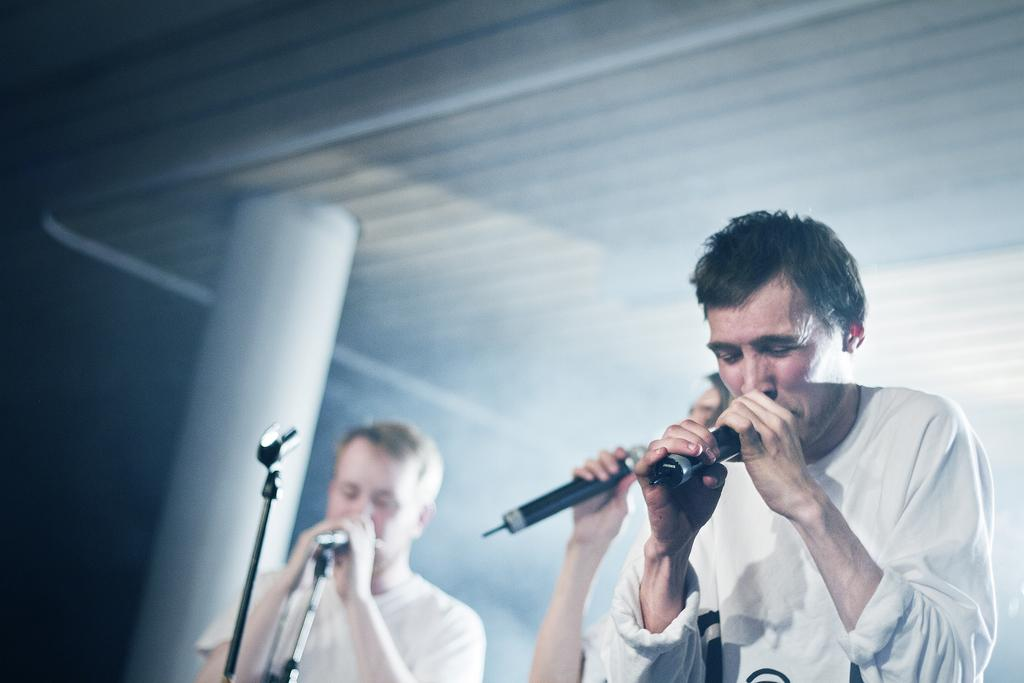Who is present in the image? There are people in the image. What are the people doing in the image? The people are holding microphones and singing. What can be seen in the background of the image? There is a pillar in the background of the image. Where is the lunchroom located in the image? There is no mention of a lunchroom in the image; it features people holding microphones and singing. What type of flower is being used as a prop in the image? There is no flower present in the image. 